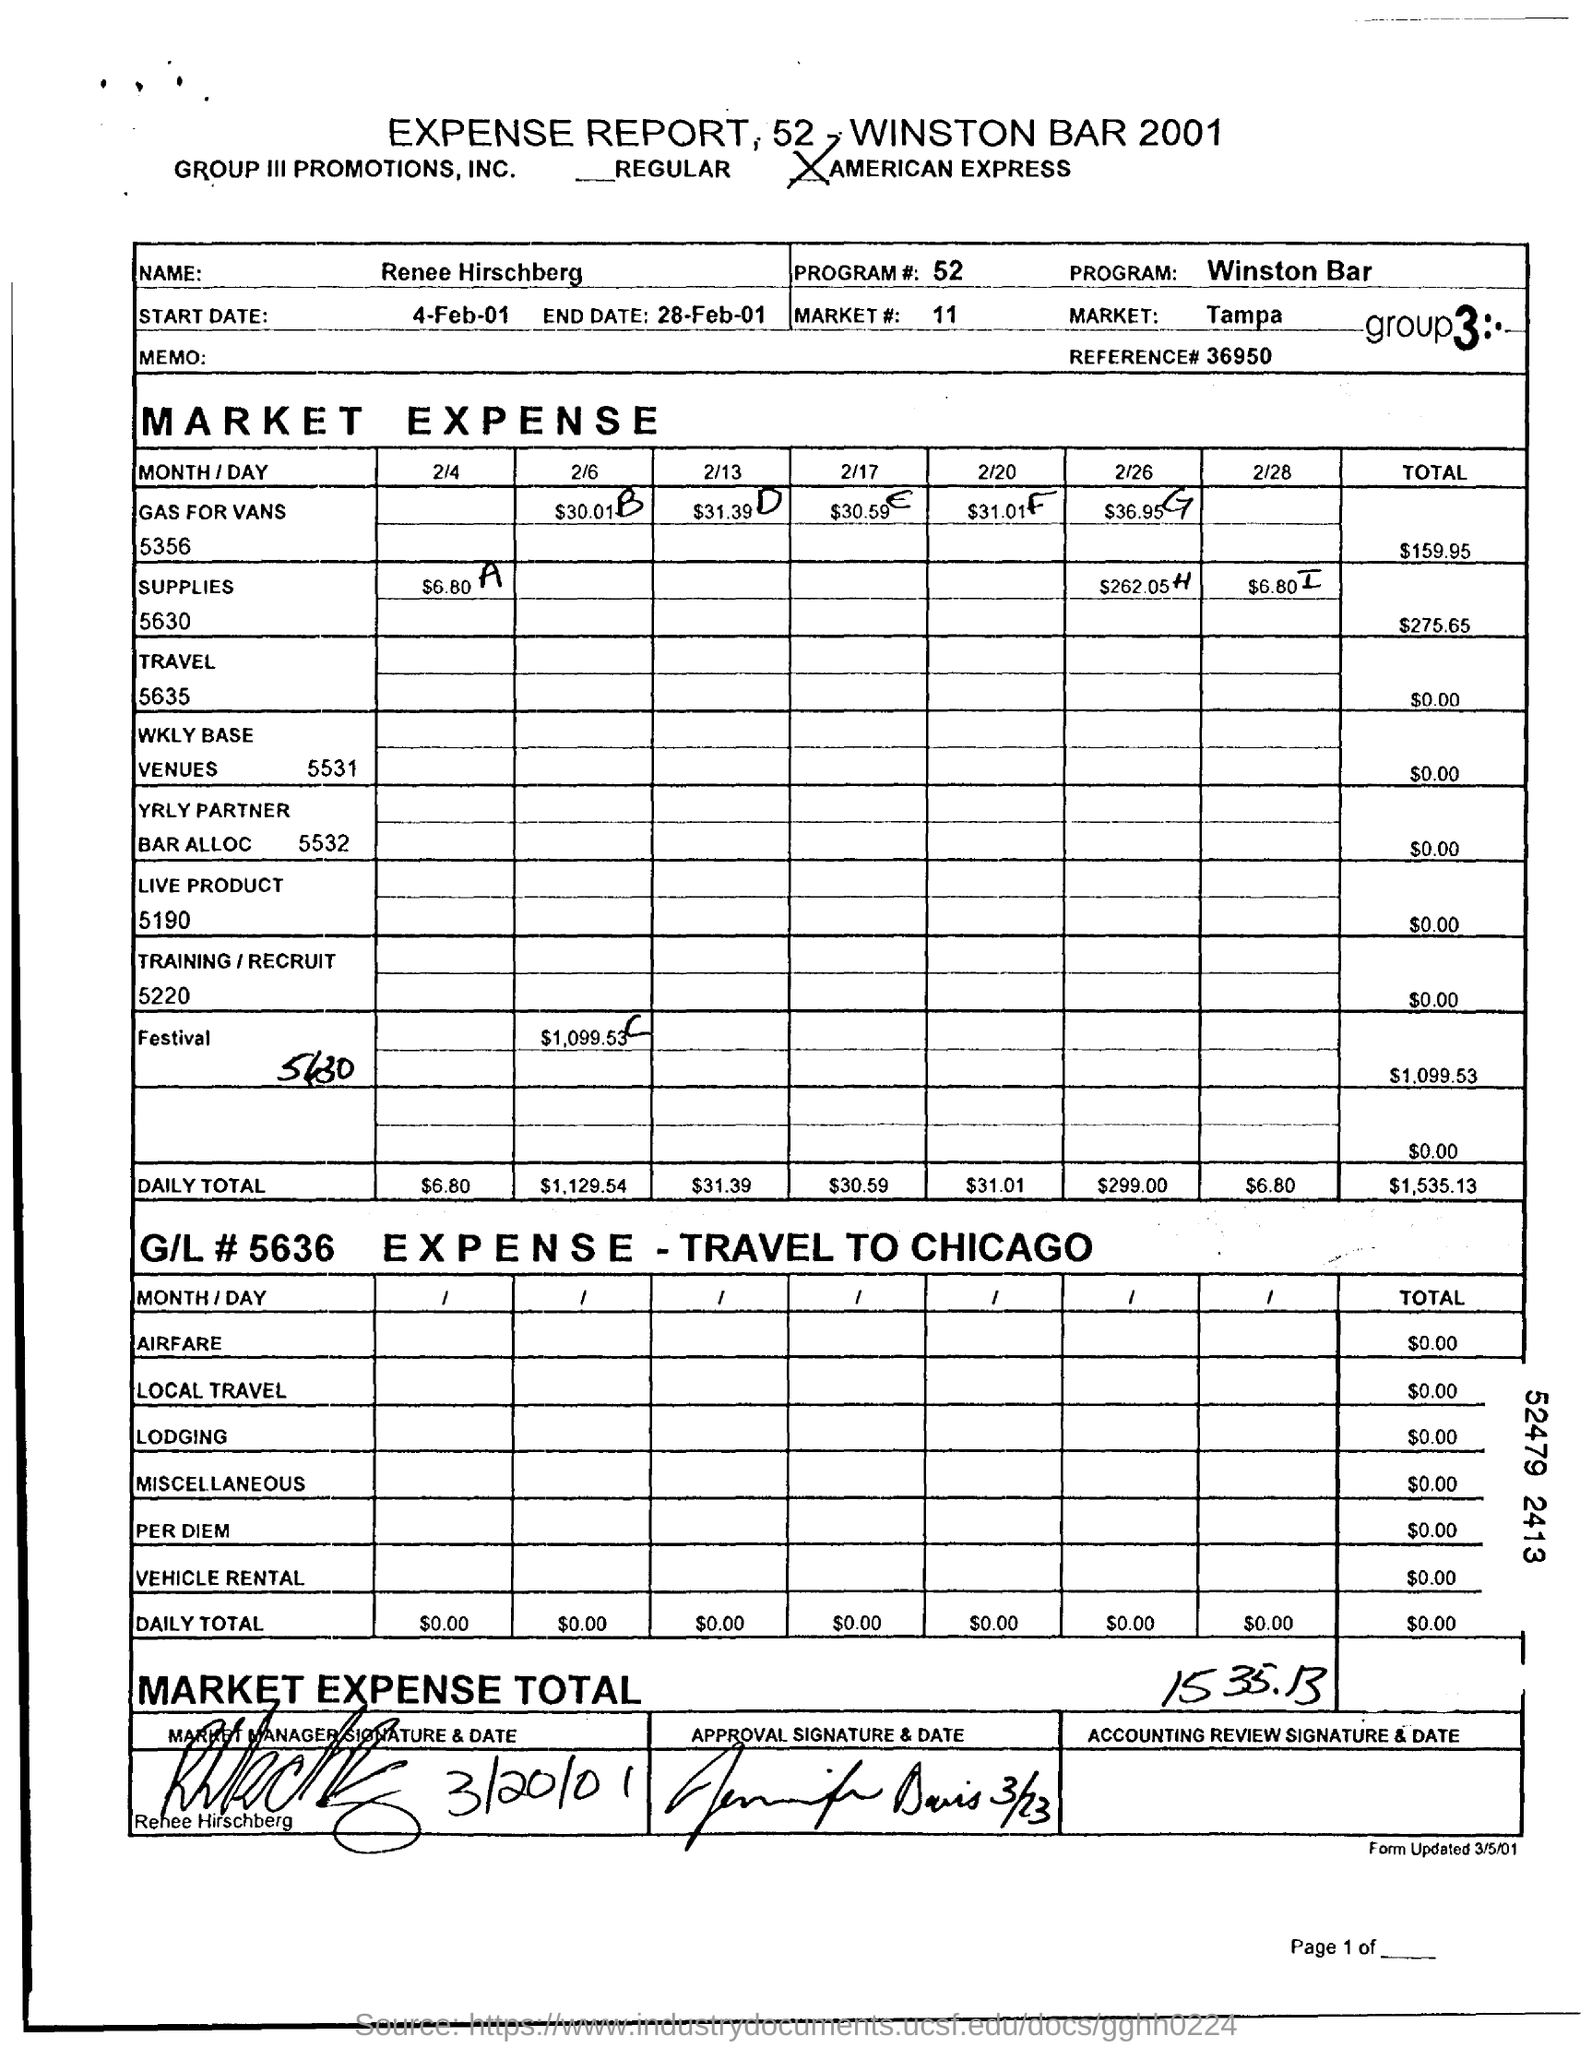What is program number mentioned on the expense report?
Your answer should be compact. 52. How much is the total Market expense mentioned on the expense report?
Your answer should be compact. 1535.13. What is the total Market expense of supplies?
Your answer should be compact. $275.65. What is the total Market expense of gas for vans?
Your response must be concise. $159.95. What is the total Market expense of festival?
Offer a terse response. $1,099.53. What is the start date mentioned in the report?
Keep it short and to the point. 4-Feb-01. 